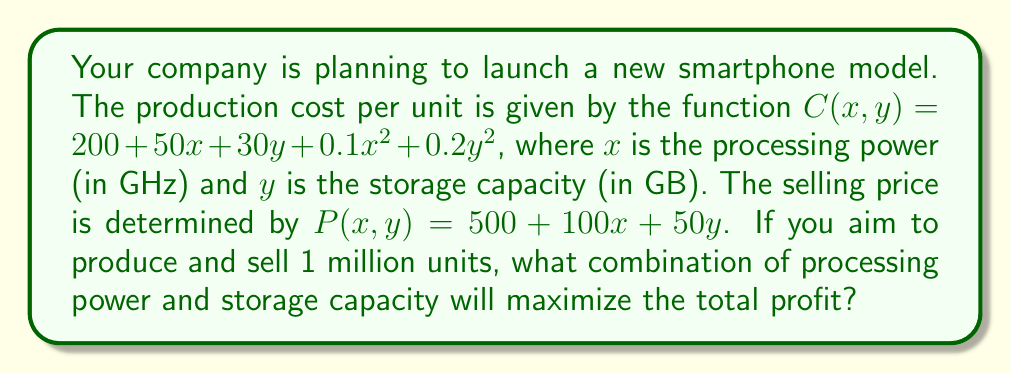Show me your answer to this math problem. To solve this problem, we'll use multivariable optimization techniques:

1) First, let's define the profit function. For 1 million units:
   $$\text{Profit} = 10^6 \cdot [\text{Price} - \text{Cost}]$$
   $$\Pi(x, y) = 10^6 \cdot [(500 + 100x + 50y) - (200 + 50x + 30y + 0.1x^2 + 0.2y^2)]$$
   $$\Pi(x, y) = 10^6 \cdot (300 + 50x + 20y - 0.1x^2 - 0.2y^2)$$

2) To find the maximum, we need to find where the partial derivatives are zero:
   $$\frac{\partial \Pi}{\partial x} = 10^6 \cdot (50 - 0.2x) = 0$$
   $$\frac{\partial \Pi}{\partial y} = 10^6 \cdot (20 - 0.4y) = 0$$

3) Solving these equations:
   $$50 - 0.2x = 0 \implies x = 250$$
   $$20 - 0.4y = 0 \implies y = 50$$

4) To confirm this is a maximum, we can check the second derivatives:
   $$\frac{\partial^2 \Pi}{\partial x^2} = -0.2 \cdot 10^6 < 0$$
   $$\frac{\partial^2 \Pi}{\partial y^2} = -0.4 \cdot 10^6 < 0$$

   The negative second derivatives confirm this is indeed a maximum.

5) Therefore, the optimal combination is 250 GHz for processing power and 50 GB for storage capacity.
Answer: 250 GHz processing power, 50 GB storage capacity 